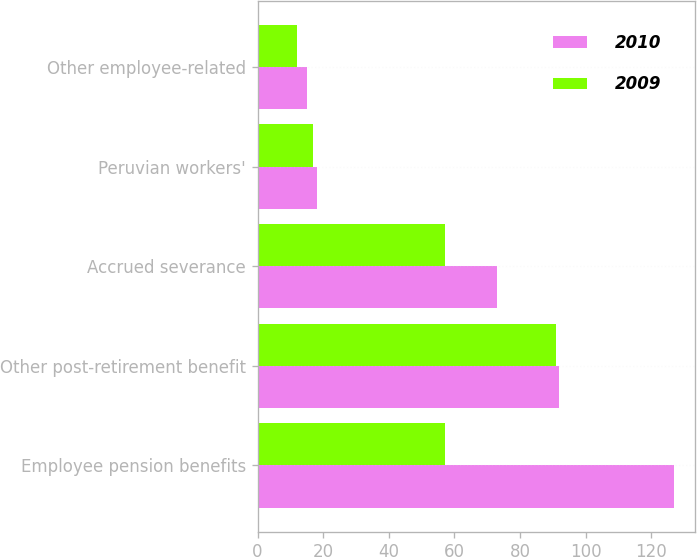Convert chart. <chart><loc_0><loc_0><loc_500><loc_500><stacked_bar_chart><ecel><fcel>Employee pension benefits<fcel>Other post-retirement benefit<fcel>Accrued severance<fcel>Peruvian workers'<fcel>Other employee-related<nl><fcel>2010<fcel>127<fcel>92<fcel>73<fcel>18<fcel>15<nl><fcel>2009<fcel>57<fcel>91<fcel>57<fcel>17<fcel>12<nl></chart> 